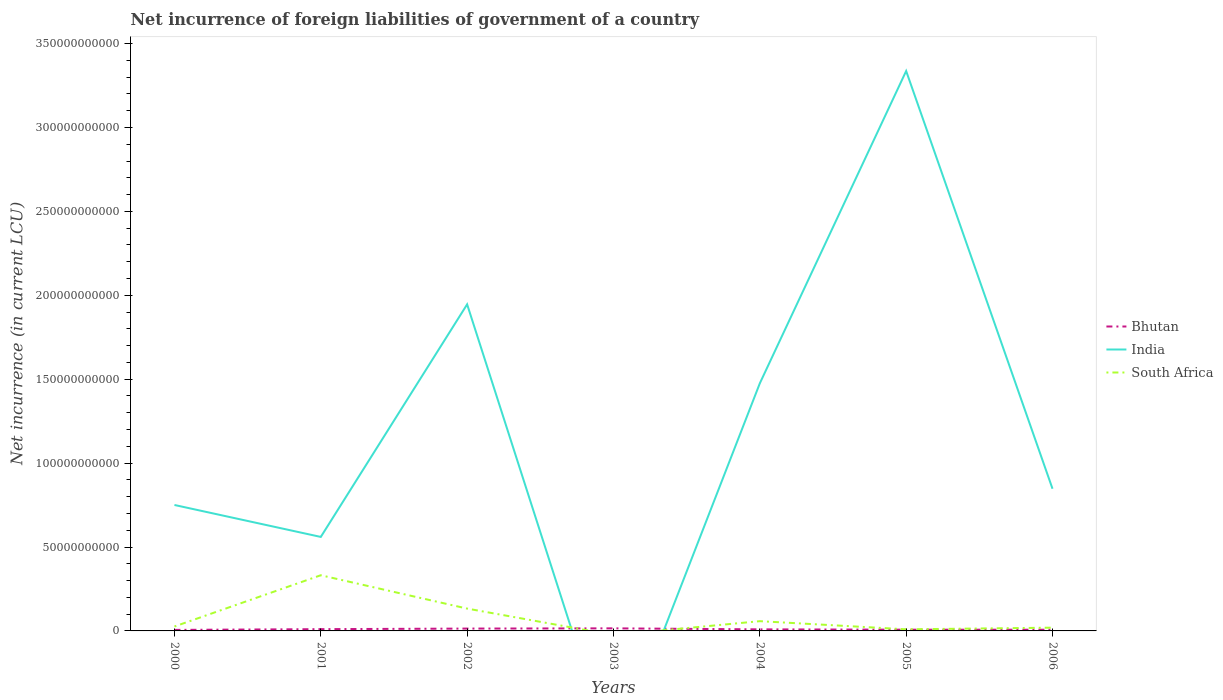Does the line corresponding to Bhutan intersect with the line corresponding to India?
Make the answer very short. Yes. What is the total net incurrence of foreign liabilities in Bhutan in the graph?
Your answer should be compact. 6.81e+08. What is the difference between the highest and the second highest net incurrence of foreign liabilities in Bhutan?
Ensure brevity in your answer.  9.31e+08. What is the difference between the highest and the lowest net incurrence of foreign liabilities in Bhutan?
Make the answer very short. 3. Does the graph contain grids?
Give a very brief answer. No. Where does the legend appear in the graph?
Ensure brevity in your answer.  Center right. How are the legend labels stacked?
Make the answer very short. Vertical. What is the title of the graph?
Offer a very short reply. Net incurrence of foreign liabilities of government of a country. What is the label or title of the Y-axis?
Provide a succinct answer. Net incurrence (in current LCU). What is the Net incurrence (in current LCU) of Bhutan in 2000?
Your response must be concise. 6.07e+08. What is the Net incurrence (in current LCU) in India in 2000?
Provide a succinct answer. 7.50e+1. What is the Net incurrence (in current LCU) of South Africa in 2000?
Give a very brief answer. 2.64e+09. What is the Net incurrence (in current LCU) of Bhutan in 2001?
Your response must be concise. 1.06e+09. What is the Net incurrence (in current LCU) of India in 2001?
Your response must be concise. 5.60e+1. What is the Net incurrence (in current LCU) of South Africa in 2001?
Your answer should be very brief. 3.32e+1. What is the Net incurrence (in current LCU) of Bhutan in 2002?
Make the answer very short. 1.40e+09. What is the Net incurrence (in current LCU) of India in 2002?
Your response must be concise. 1.95e+11. What is the Net incurrence (in current LCU) in South Africa in 2002?
Make the answer very short. 1.33e+1. What is the Net incurrence (in current LCU) of Bhutan in 2003?
Offer a very short reply. 1.54e+09. What is the Net incurrence (in current LCU) of South Africa in 2003?
Your response must be concise. 0. What is the Net incurrence (in current LCU) of Bhutan in 2004?
Provide a short and direct response. 9.32e+08. What is the Net incurrence (in current LCU) of India in 2004?
Your answer should be very brief. 1.48e+11. What is the Net incurrence (in current LCU) in South Africa in 2004?
Ensure brevity in your answer.  5.81e+09. What is the Net incurrence (in current LCU) in Bhutan in 2005?
Give a very brief answer. 7.39e+08. What is the Net incurrence (in current LCU) in India in 2005?
Provide a short and direct response. 3.34e+11. What is the Net incurrence (in current LCU) in South Africa in 2005?
Your answer should be compact. 9.50e+08. What is the Net incurrence (in current LCU) of Bhutan in 2006?
Give a very brief answer. 7.15e+08. What is the Net incurrence (in current LCU) in India in 2006?
Provide a short and direct response. 8.47e+1. What is the Net incurrence (in current LCU) of South Africa in 2006?
Your answer should be compact. 1.94e+09. Across all years, what is the maximum Net incurrence (in current LCU) of Bhutan?
Your response must be concise. 1.54e+09. Across all years, what is the maximum Net incurrence (in current LCU) of India?
Offer a very short reply. 3.34e+11. Across all years, what is the maximum Net incurrence (in current LCU) of South Africa?
Provide a short and direct response. 3.32e+1. Across all years, what is the minimum Net incurrence (in current LCU) in Bhutan?
Provide a succinct answer. 6.07e+08. What is the total Net incurrence (in current LCU) of Bhutan in the graph?
Your answer should be very brief. 6.98e+09. What is the total Net incurrence (in current LCU) in India in the graph?
Your answer should be compact. 8.92e+11. What is the total Net incurrence (in current LCU) of South Africa in the graph?
Your answer should be compact. 5.78e+1. What is the difference between the Net incurrence (in current LCU) of Bhutan in 2000 and that in 2001?
Give a very brief answer. -4.50e+08. What is the difference between the Net incurrence (in current LCU) in India in 2000 and that in 2001?
Your response must be concise. 1.90e+1. What is the difference between the Net incurrence (in current LCU) in South Africa in 2000 and that in 2001?
Give a very brief answer. -3.05e+1. What is the difference between the Net incurrence (in current LCU) in Bhutan in 2000 and that in 2002?
Give a very brief answer. -7.90e+08. What is the difference between the Net incurrence (in current LCU) in India in 2000 and that in 2002?
Ensure brevity in your answer.  -1.20e+11. What is the difference between the Net incurrence (in current LCU) of South Africa in 2000 and that in 2002?
Provide a succinct answer. -1.07e+1. What is the difference between the Net incurrence (in current LCU) of Bhutan in 2000 and that in 2003?
Offer a terse response. -9.31e+08. What is the difference between the Net incurrence (in current LCU) in Bhutan in 2000 and that in 2004?
Offer a terse response. -3.26e+08. What is the difference between the Net incurrence (in current LCU) in India in 2000 and that in 2004?
Ensure brevity in your answer.  -7.25e+1. What is the difference between the Net incurrence (in current LCU) of South Africa in 2000 and that in 2004?
Provide a succinct answer. -3.17e+09. What is the difference between the Net incurrence (in current LCU) of Bhutan in 2000 and that in 2005?
Offer a terse response. -1.33e+08. What is the difference between the Net incurrence (in current LCU) in India in 2000 and that in 2005?
Make the answer very short. -2.59e+11. What is the difference between the Net incurrence (in current LCU) of South Africa in 2000 and that in 2005?
Provide a succinct answer. 1.69e+09. What is the difference between the Net incurrence (in current LCU) in Bhutan in 2000 and that in 2006?
Provide a succinct answer. -1.09e+08. What is the difference between the Net incurrence (in current LCU) of India in 2000 and that in 2006?
Give a very brief answer. -9.67e+09. What is the difference between the Net incurrence (in current LCU) in South Africa in 2000 and that in 2006?
Offer a terse response. 6.94e+08. What is the difference between the Net incurrence (in current LCU) in Bhutan in 2001 and that in 2002?
Your answer should be compact. -3.40e+08. What is the difference between the Net incurrence (in current LCU) of India in 2001 and that in 2002?
Give a very brief answer. -1.39e+11. What is the difference between the Net incurrence (in current LCU) of South Africa in 2001 and that in 2002?
Give a very brief answer. 1.99e+1. What is the difference between the Net incurrence (in current LCU) of Bhutan in 2001 and that in 2003?
Provide a short and direct response. -4.81e+08. What is the difference between the Net incurrence (in current LCU) of Bhutan in 2001 and that in 2004?
Offer a very short reply. 1.25e+08. What is the difference between the Net incurrence (in current LCU) in India in 2001 and that in 2004?
Your answer should be very brief. -9.15e+1. What is the difference between the Net incurrence (in current LCU) in South Africa in 2001 and that in 2004?
Your answer should be compact. 2.74e+1. What is the difference between the Net incurrence (in current LCU) in Bhutan in 2001 and that in 2005?
Your answer should be very brief. 3.17e+08. What is the difference between the Net incurrence (in current LCU) in India in 2001 and that in 2005?
Provide a short and direct response. -2.78e+11. What is the difference between the Net incurrence (in current LCU) in South Africa in 2001 and that in 2005?
Your response must be concise. 3.22e+1. What is the difference between the Net incurrence (in current LCU) of Bhutan in 2001 and that in 2006?
Your response must be concise. 3.41e+08. What is the difference between the Net incurrence (in current LCU) of India in 2001 and that in 2006?
Offer a terse response. -2.87e+1. What is the difference between the Net incurrence (in current LCU) in South Africa in 2001 and that in 2006?
Provide a succinct answer. 3.12e+1. What is the difference between the Net incurrence (in current LCU) of Bhutan in 2002 and that in 2003?
Offer a very short reply. -1.41e+08. What is the difference between the Net incurrence (in current LCU) of Bhutan in 2002 and that in 2004?
Keep it short and to the point. 4.65e+08. What is the difference between the Net incurrence (in current LCU) of India in 2002 and that in 2004?
Offer a terse response. 4.71e+1. What is the difference between the Net incurrence (in current LCU) in South Africa in 2002 and that in 2004?
Offer a very short reply. 7.50e+09. What is the difference between the Net incurrence (in current LCU) in Bhutan in 2002 and that in 2005?
Your answer should be very brief. 6.57e+08. What is the difference between the Net incurrence (in current LCU) in India in 2002 and that in 2005?
Offer a terse response. -1.39e+11. What is the difference between the Net incurrence (in current LCU) of South Africa in 2002 and that in 2005?
Offer a terse response. 1.24e+1. What is the difference between the Net incurrence (in current LCU) of Bhutan in 2002 and that in 2006?
Make the answer very short. 6.81e+08. What is the difference between the Net incurrence (in current LCU) in India in 2002 and that in 2006?
Keep it short and to the point. 1.10e+11. What is the difference between the Net incurrence (in current LCU) of South Africa in 2002 and that in 2006?
Offer a terse response. 1.14e+1. What is the difference between the Net incurrence (in current LCU) in Bhutan in 2003 and that in 2004?
Ensure brevity in your answer.  6.05e+08. What is the difference between the Net incurrence (in current LCU) of Bhutan in 2003 and that in 2005?
Make the answer very short. 7.98e+08. What is the difference between the Net incurrence (in current LCU) of Bhutan in 2003 and that in 2006?
Your answer should be compact. 8.22e+08. What is the difference between the Net incurrence (in current LCU) of Bhutan in 2004 and that in 2005?
Give a very brief answer. 1.93e+08. What is the difference between the Net incurrence (in current LCU) in India in 2004 and that in 2005?
Your answer should be very brief. -1.86e+11. What is the difference between the Net incurrence (in current LCU) of South Africa in 2004 and that in 2005?
Keep it short and to the point. 4.86e+09. What is the difference between the Net incurrence (in current LCU) of Bhutan in 2004 and that in 2006?
Keep it short and to the point. 2.17e+08. What is the difference between the Net incurrence (in current LCU) of India in 2004 and that in 2006?
Make the answer very short. 6.28e+1. What is the difference between the Net incurrence (in current LCU) in South Africa in 2004 and that in 2006?
Provide a succinct answer. 3.87e+09. What is the difference between the Net incurrence (in current LCU) in Bhutan in 2005 and that in 2006?
Your answer should be compact. 2.39e+07. What is the difference between the Net incurrence (in current LCU) of India in 2005 and that in 2006?
Offer a terse response. 2.49e+11. What is the difference between the Net incurrence (in current LCU) in South Africa in 2005 and that in 2006?
Offer a terse response. -9.93e+08. What is the difference between the Net incurrence (in current LCU) of Bhutan in 2000 and the Net incurrence (in current LCU) of India in 2001?
Offer a very short reply. -5.54e+1. What is the difference between the Net incurrence (in current LCU) of Bhutan in 2000 and the Net incurrence (in current LCU) of South Africa in 2001?
Your response must be concise. -3.26e+1. What is the difference between the Net incurrence (in current LCU) of India in 2000 and the Net incurrence (in current LCU) of South Africa in 2001?
Your answer should be very brief. 4.19e+1. What is the difference between the Net incurrence (in current LCU) of Bhutan in 2000 and the Net incurrence (in current LCU) of India in 2002?
Provide a succinct answer. -1.94e+11. What is the difference between the Net incurrence (in current LCU) in Bhutan in 2000 and the Net incurrence (in current LCU) in South Africa in 2002?
Offer a very short reply. -1.27e+1. What is the difference between the Net incurrence (in current LCU) in India in 2000 and the Net incurrence (in current LCU) in South Africa in 2002?
Your answer should be very brief. 6.17e+1. What is the difference between the Net incurrence (in current LCU) of Bhutan in 2000 and the Net incurrence (in current LCU) of India in 2004?
Provide a short and direct response. -1.47e+11. What is the difference between the Net incurrence (in current LCU) in Bhutan in 2000 and the Net incurrence (in current LCU) in South Africa in 2004?
Keep it short and to the point. -5.20e+09. What is the difference between the Net incurrence (in current LCU) in India in 2000 and the Net incurrence (in current LCU) in South Africa in 2004?
Keep it short and to the point. 6.92e+1. What is the difference between the Net incurrence (in current LCU) in Bhutan in 2000 and the Net incurrence (in current LCU) in India in 2005?
Ensure brevity in your answer.  -3.33e+11. What is the difference between the Net incurrence (in current LCU) in Bhutan in 2000 and the Net incurrence (in current LCU) in South Africa in 2005?
Give a very brief answer. -3.43e+08. What is the difference between the Net incurrence (in current LCU) in India in 2000 and the Net incurrence (in current LCU) in South Africa in 2005?
Your answer should be very brief. 7.41e+1. What is the difference between the Net incurrence (in current LCU) of Bhutan in 2000 and the Net incurrence (in current LCU) of India in 2006?
Offer a terse response. -8.41e+1. What is the difference between the Net incurrence (in current LCU) in Bhutan in 2000 and the Net incurrence (in current LCU) in South Africa in 2006?
Your answer should be compact. -1.34e+09. What is the difference between the Net incurrence (in current LCU) of India in 2000 and the Net incurrence (in current LCU) of South Africa in 2006?
Provide a short and direct response. 7.31e+1. What is the difference between the Net incurrence (in current LCU) in Bhutan in 2001 and the Net incurrence (in current LCU) in India in 2002?
Offer a very short reply. -1.94e+11. What is the difference between the Net incurrence (in current LCU) of Bhutan in 2001 and the Net incurrence (in current LCU) of South Africa in 2002?
Your response must be concise. -1.23e+1. What is the difference between the Net incurrence (in current LCU) of India in 2001 and the Net incurrence (in current LCU) of South Africa in 2002?
Offer a terse response. 4.27e+1. What is the difference between the Net incurrence (in current LCU) in Bhutan in 2001 and the Net incurrence (in current LCU) in India in 2004?
Ensure brevity in your answer.  -1.46e+11. What is the difference between the Net incurrence (in current LCU) in Bhutan in 2001 and the Net incurrence (in current LCU) in South Africa in 2004?
Provide a succinct answer. -4.75e+09. What is the difference between the Net incurrence (in current LCU) of India in 2001 and the Net incurrence (in current LCU) of South Africa in 2004?
Your answer should be very brief. 5.02e+1. What is the difference between the Net incurrence (in current LCU) in Bhutan in 2001 and the Net incurrence (in current LCU) in India in 2005?
Make the answer very short. -3.33e+11. What is the difference between the Net incurrence (in current LCU) of Bhutan in 2001 and the Net incurrence (in current LCU) of South Africa in 2005?
Offer a very short reply. 1.07e+08. What is the difference between the Net incurrence (in current LCU) in India in 2001 and the Net incurrence (in current LCU) in South Africa in 2005?
Give a very brief answer. 5.51e+1. What is the difference between the Net incurrence (in current LCU) in Bhutan in 2001 and the Net incurrence (in current LCU) in India in 2006?
Provide a short and direct response. -8.37e+1. What is the difference between the Net incurrence (in current LCU) of Bhutan in 2001 and the Net incurrence (in current LCU) of South Africa in 2006?
Your answer should be very brief. -8.86e+08. What is the difference between the Net incurrence (in current LCU) in India in 2001 and the Net incurrence (in current LCU) in South Africa in 2006?
Provide a succinct answer. 5.41e+1. What is the difference between the Net incurrence (in current LCU) in Bhutan in 2002 and the Net incurrence (in current LCU) in India in 2004?
Offer a very short reply. -1.46e+11. What is the difference between the Net incurrence (in current LCU) of Bhutan in 2002 and the Net incurrence (in current LCU) of South Africa in 2004?
Keep it short and to the point. -4.41e+09. What is the difference between the Net incurrence (in current LCU) of India in 2002 and the Net incurrence (in current LCU) of South Africa in 2004?
Your response must be concise. 1.89e+11. What is the difference between the Net incurrence (in current LCU) of Bhutan in 2002 and the Net incurrence (in current LCU) of India in 2005?
Your answer should be compact. -3.32e+11. What is the difference between the Net incurrence (in current LCU) of Bhutan in 2002 and the Net incurrence (in current LCU) of South Africa in 2005?
Your response must be concise. 4.47e+08. What is the difference between the Net incurrence (in current LCU) in India in 2002 and the Net incurrence (in current LCU) in South Africa in 2005?
Your answer should be very brief. 1.94e+11. What is the difference between the Net incurrence (in current LCU) in Bhutan in 2002 and the Net incurrence (in current LCU) in India in 2006?
Offer a very short reply. -8.33e+1. What is the difference between the Net incurrence (in current LCU) of Bhutan in 2002 and the Net incurrence (in current LCU) of South Africa in 2006?
Provide a succinct answer. -5.46e+08. What is the difference between the Net incurrence (in current LCU) in India in 2002 and the Net incurrence (in current LCU) in South Africa in 2006?
Ensure brevity in your answer.  1.93e+11. What is the difference between the Net incurrence (in current LCU) in Bhutan in 2003 and the Net incurrence (in current LCU) in India in 2004?
Provide a succinct answer. -1.46e+11. What is the difference between the Net incurrence (in current LCU) in Bhutan in 2003 and the Net incurrence (in current LCU) in South Africa in 2004?
Provide a succinct answer. -4.27e+09. What is the difference between the Net incurrence (in current LCU) in Bhutan in 2003 and the Net incurrence (in current LCU) in India in 2005?
Your answer should be compact. -3.32e+11. What is the difference between the Net incurrence (in current LCU) of Bhutan in 2003 and the Net incurrence (in current LCU) of South Africa in 2005?
Your answer should be very brief. 5.87e+08. What is the difference between the Net incurrence (in current LCU) in Bhutan in 2003 and the Net incurrence (in current LCU) in India in 2006?
Your answer should be compact. -8.32e+1. What is the difference between the Net incurrence (in current LCU) of Bhutan in 2003 and the Net incurrence (in current LCU) of South Africa in 2006?
Your response must be concise. -4.06e+08. What is the difference between the Net incurrence (in current LCU) in Bhutan in 2004 and the Net incurrence (in current LCU) in India in 2005?
Offer a terse response. -3.33e+11. What is the difference between the Net incurrence (in current LCU) in Bhutan in 2004 and the Net incurrence (in current LCU) in South Africa in 2005?
Give a very brief answer. -1.79e+07. What is the difference between the Net incurrence (in current LCU) in India in 2004 and the Net incurrence (in current LCU) in South Africa in 2005?
Provide a succinct answer. 1.47e+11. What is the difference between the Net incurrence (in current LCU) of Bhutan in 2004 and the Net incurrence (in current LCU) of India in 2006?
Make the answer very short. -8.38e+1. What is the difference between the Net incurrence (in current LCU) of Bhutan in 2004 and the Net incurrence (in current LCU) of South Africa in 2006?
Your answer should be very brief. -1.01e+09. What is the difference between the Net incurrence (in current LCU) of India in 2004 and the Net incurrence (in current LCU) of South Africa in 2006?
Make the answer very short. 1.46e+11. What is the difference between the Net incurrence (in current LCU) of Bhutan in 2005 and the Net incurrence (in current LCU) of India in 2006?
Make the answer very short. -8.40e+1. What is the difference between the Net incurrence (in current LCU) in Bhutan in 2005 and the Net incurrence (in current LCU) in South Africa in 2006?
Give a very brief answer. -1.20e+09. What is the difference between the Net incurrence (in current LCU) of India in 2005 and the Net incurrence (in current LCU) of South Africa in 2006?
Your answer should be very brief. 3.32e+11. What is the average Net incurrence (in current LCU) in Bhutan per year?
Provide a short and direct response. 9.98e+08. What is the average Net incurrence (in current LCU) of India per year?
Your response must be concise. 1.27e+11. What is the average Net incurrence (in current LCU) in South Africa per year?
Give a very brief answer. 8.26e+09. In the year 2000, what is the difference between the Net incurrence (in current LCU) in Bhutan and Net incurrence (in current LCU) in India?
Your response must be concise. -7.44e+1. In the year 2000, what is the difference between the Net incurrence (in current LCU) of Bhutan and Net incurrence (in current LCU) of South Africa?
Keep it short and to the point. -2.03e+09. In the year 2000, what is the difference between the Net incurrence (in current LCU) of India and Net incurrence (in current LCU) of South Africa?
Your response must be concise. 7.24e+1. In the year 2001, what is the difference between the Net incurrence (in current LCU) in Bhutan and Net incurrence (in current LCU) in India?
Ensure brevity in your answer.  -5.50e+1. In the year 2001, what is the difference between the Net incurrence (in current LCU) in Bhutan and Net incurrence (in current LCU) in South Africa?
Your response must be concise. -3.21e+1. In the year 2001, what is the difference between the Net incurrence (in current LCU) of India and Net incurrence (in current LCU) of South Africa?
Your response must be concise. 2.28e+1. In the year 2002, what is the difference between the Net incurrence (in current LCU) in Bhutan and Net incurrence (in current LCU) in India?
Provide a succinct answer. -1.93e+11. In the year 2002, what is the difference between the Net incurrence (in current LCU) of Bhutan and Net incurrence (in current LCU) of South Africa?
Provide a short and direct response. -1.19e+1. In the year 2002, what is the difference between the Net incurrence (in current LCU) in India and Net incurrence (in current LCU) in South Africa?
Give a very brief answer. 1.81e+11. In the year 2004, what is the difference between the Net incurrence (in current LCU) of Bhutan and Net incurrence (in current LCU) of India?
Ensure brevity in your answer.  -1.47e+11. In the year 2004, what is the difference between the Net incurrence (in current LCU) in Bhutan and Net incurrence (in current LCU) in South Africa?
Your answer should be very brief. -4.88e+09. In the year 2004, what is the difference between the Net incurrence (in current LCU) of India and Net incurrence (in current LCU) of South Africa?
Keep it short and to the point. 1.42e+11. In the year 2005, what is the difference between the Net incurrence (in current LCU) of Bhutan and Net incurrence (in current LCU) of India?
Your answer should be very brief. -3.33e+11. In the year 2005, what is the difference between the Net incurrence (in current LCU) of Bhutan and Net incurrence (in current LCU) of South Africa?
Your answer should be compact. -2.11e+08. In the year 2005, what is the difference between the Net incurrence (in current LCU) in India and Net incurrence (in current LCU) in South Africa?
Make the answer very short. 3.33e+11. In the year 2006, what is the difference between the Net incurrence (in current LCU) of Bhutan and Net incurrence (in current LCU) of India?
Ensure brevity in your answer.  -8.40e+1. In the year 2006, what is the difference between the Net incurrence (in current LCU) in Bhutan and Net incurrence (in current LCU) in South Africa?
Your response must be concise. -1.23e+09. In the year 2006, what is the difference between the Net incurrence (in current LCU) of India and Net incurrence (in current LCU) of South Africa?
Keep it short and to the point. 8.28e+1. What is the ratio of the Net incurrence (in current LCU) in Bhutan in 2000 to that in 2001?
Offer a very short reply. 0.57. What is the ratio of the Net incurrence (in current LCU) in India in 2000 to that in 2001?
Your response must be concise. 1.34. What is the ratio of the Net incurrence (in current LCU) in South Africa in 2000 to that in 2001?
Make the answer very short. 0.08. What is the ratio of the Net incurrence (in current LCU) in Bhutan in 2000 to that in 2002?
Provide a succinct answer. 0.43. What is the ratio of the Net incurrence (in current LCU) of India in 2000 to that in 2002?
Offer a very short reply. 0.39. What is the ratio of the Net incurrence (in current LCU) of South Africa in 2000 to that in 2002?
Keep it short and to the point. 0.2. What is the ratio of the Net incurrence (in current LCU) in Bhutan in 2000 to that in 2003?
Make the answer very short. 0.39. What is the ratio of the Net incurrence (in current LCU) in Bhutan in 2000 to that in 2004?
Ensure brevity in your answer.  0.65. What is the ratio of the Net incurrence (in current LCU) in India in 2000 to that in 2004?
Your answer should be very brief. 0.51. What is the ratio of the Net incurrence (in current LCU) of South Africa in 2000 to that in 2004?
Your response must be concise. 0.45. What is the ratio of the Net incurrence (in current LCU) in Bhutan in 2000 to that in 2005?
Give a very brief answer. 0.82. What is the ratio of the Net incurrence (in current LCU) of India in 2000 to that in 2005?
Give a very brief answer. 0.22. What is the ratio of the Net incurrence (in current LCU) of South Africa in 2000 to that in 2005?
Your answer should be very brief. 2.78. What is the ratio of the Net incurrence (in current LCU) in Bhutan in 2000 to that in 2006?
Your answer should be very brief. 0.85. What is the ratio of the Net incurrence (in current LCU) in India in 2000 to that in 2006?
Keep it short and to the point. 0.89. What is the ratio of the Net incurrence (in current LCU) of South Africa in 2000 to that in 2006?
Keep it short and to the point. 1.36. What is the ratio of the Net incurrence (in current LCU) of Bhutan in 2001 to that in 2002?
Make the answer very short. 0.76. What is the ratio of the Net incurrence (in current LCU) in India in 2001 to that in 2002?
Make the answer very short. 0.29. What is the ratio of the Net incurrence (in current LCU) in South Africa in 2001 to that in 2002?
Your answer should be very brief. 2.49. What is the ratio of the Net incurrence (in current LCU) in Bhutan in 2001 to that in 2003?
Your response must be concise. 0.69. What is the ratio of the Net incurrence (in current LCU) in Bhutan in 2001 to that in 2004?
Provide a succinct answer. 1.13. What is the ratio of the Net incurrence (in current LCU) of India in 2001 to that in 2004?
Keep it short and to the point. 0.38. What is the ratio of the Net incurrence (in current LCU) of South Africa in 2001 to that in 2004?
Offer a terse response. 5.71. What is the ratio of the Net incurrence (in current LCU) in Bhutan in 2001 to that in 2005?
Provide a succinct answer. 1.43. What is the ratio of the Net incurrence (in current LCU) of India in 2001 to that in 2005?
Your answer should be very brief. 0.17. What is the ratio of the Net incurrence (in current LCU) in South Africa in 2001 to that in 2005?
Offer a very short reply. 34.92. What is the ratio of the Net incurrence (in current LCU) in Bhutan in 2001 to that in 2006?
Provide a short and direct response. 1.48. What is the ratio of the Net incurrence (in current LCU) of India in 2001 to that in 2006?
Ensure brevity in your answer.  0.66. What is the ratio of the Net incurrence (in current LCU) in South Africa in 2001 to that in 2006?
Keep it short and to the point. 17.08. What is the ratio of the Net incurrence (in current LCU) in Bhutan in 2002 to that in 2003?
Provide a succinct answer. 0.91. What is the ratio of the Net incurrence (in current LCU) of Bhutan in 2002 to that in 2004?
Your answer should be very brief. 1.5. What is the ratio of the Net incurrence (in current LCU) of India in 2002 to that in 2004?
Offer a very short reply. 1.32. What is the ratio of the Net incurrence (in current LCU) in South Africa in 2002 to that in 2004?
Give a very brief answer. 2.29. What is the ratio of the Net incurrence (in current LCU) in Bhutan in 2002 to that in 2005?
Offer a very short reply. 1.89. What is the ratio of the Net incurrence (in current LCU) of India in 2002 to that in 2005?
Offer a terse response. 0.58. What is the ratio of the Net incurrence (in current LCU) in South Africa in 2002 to that in 2005?
Make the answer very short. 14.01. What is the ratio of the Net incurrence (in current LCU) in Bhutan in 2002 to that in 2006?
Your answer should be very brief. 1.95. What is the ratio of the Net incurrence (in current LCU) in India in 2002 to that in 2006?
Give a very brief answer. 2.3. What is the ratio of the Net incurrence (in current LCU) of South Africa in 2002 to that in 2006?
Keep it short and to the point. 6.85. What is the ratio of the Net incurrence (in current LCU) in Bhutan in 2003 to that in 2004?
Offer a very short reply. 1.65. What is the ratio of the Net incurrence (in current LCU) in Bhutan in 2003 to that in 2005?
Ensure brevity in your answer.  2.08. What is the ratio of the Net incurrence (in current LCU) of Bhutan in 2003 to that in 2006?
Your answer should be very brief. 2.15. What is the ratio of the Net incurrence (in current LCU) of Bhutan in 2004 to that in 2005?
Your response must be concise. 1.26. What is the ratio of the Net incurrence (in current LCU) in India in 2004 to that in 2005?
Offer a very short reply. 0.44. What is the ratio of the Net incurrence (in current LCU) in South Africa in 2004 to that in 2005?
Your response must be concise. 6.11. What is the ratio of the Net incurrence (in current LCU) of Bhutan in 2004 to that in 2006?
Ensure brevity in your answer.  1.3. What is the ratio of the Net incurrence (in current LCU) in India in 2004 to that in 2006?
Offer a very short reply. 1.74. What is the ratio of the Net incurrence (in current LCU) of South Africa in 2004 to that in 2006?
Make the answer very short. 2.99. What is the ratio of the Net incurrence (in current LCU) of Bhutan in 2005 to that in 2006?
Your response must be concise. 1.03. What is the ratio of the Net incurrence (in current LCU) of India in 2005 to that in 2006?
Your answer should be compact. 3.94. What is the ratio of the Net incurrence (in current LCU) of South Africa in 2005 to that in 2006?
Your response must be concise. 0.49. What is the difference between the highest and the second highest Net incurrence (in current LCU) in Bhutan?
Offer a terse response. 1.41e+08. What is the difference between the highest and the second highest Net incurrence (in current LCU) of India?
Offer a terse response. 1.39e+11. What is the difference between the highest and the second highest Net incurrence (in current LCU) of South Africa?
Provide a succinct answer. 1.99e+1. What is the difference between the highest and the lowest Net incurrence (in current LCU) of Bhutan?
Provide a short and direct response. 9.31e+08. What is the difference between the highest and the lowest Net incurrence (in current LCU) of India?
Offer a very short reply. 3.34e+11. What is the difference between the highest and the lowest Net incurrence (in current LCU) of South Africa?
Provide a short and direct response. 3.32e+1. 